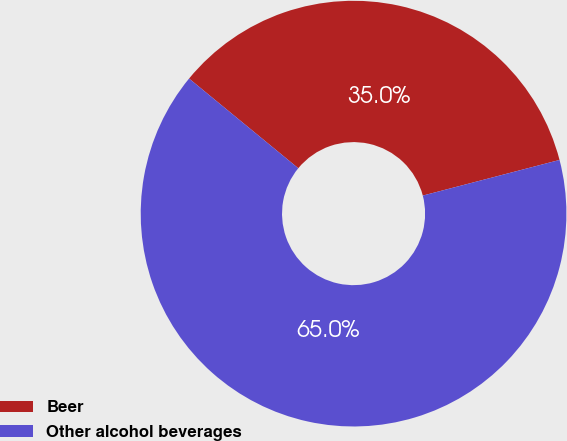Convert chart to OTSL. <chart><loc_0><loc_0><loc_500><loc_500><pie_chart><fcel>Beer<fcel>Other alcohol beverages<nl><fcel>35.0%<fcel>65.0%<nl></chart> 